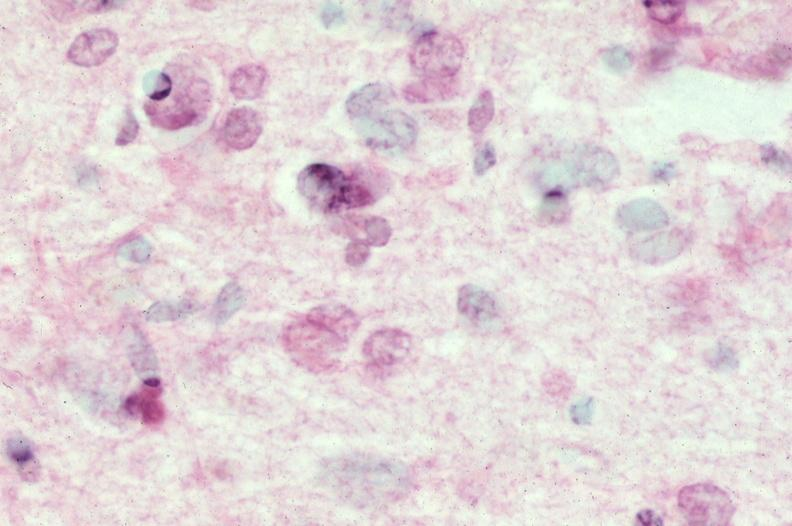where is this?
Answer the question using a single word or phrase. Nervous 